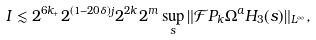<formula> <loc_0><loc_0><loc_500><loc_500>I & \lesssim 2 ^ { 6 k _ { + } } 2 ^ { ( 1 - 2 0 \delta ) j } 2 ^ { 2 k } 2 ^ { m } \sup _ { s } \| \mathcal { F } P _ { k } \Omega ^ { a } H _ { 3 } ( s ) \| _ { L ^ { \infty } } ,</formula> 